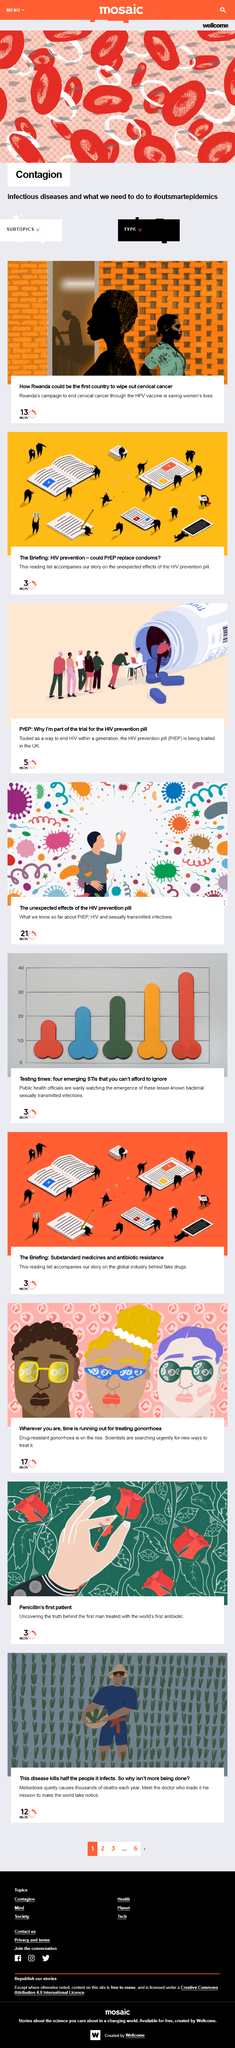List a handful of essential elements in this visual. Rwanda could be the first country to eliminate cervical cancer. Scientists are currently seeking new methods for treating drug-resistant gonorrhoea, which is a pressing health concern. The middle image's picture graph indicates a rise in bacterial sexually transmitted infections. Melioidosis is a disease that is known to cause significant morbidity and mortality, with approximately half of the individuals who contract the infection succumbing to the disease. Gonorrhoea is becoming more resistant to antibiotics, which is a significant public health concern. The rise of drug-resistant gonorrhoea is a major concern that requires immediate attention and action. 